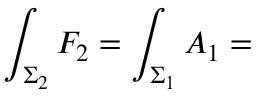<formula> <loc_0><loc_0><loc_500><loc_500>\int _ { \Sigma _ { 2 } } F _ { 2 } = \int _ { \Sigma _ { 1 } } A _ { 1 } =</formula> 